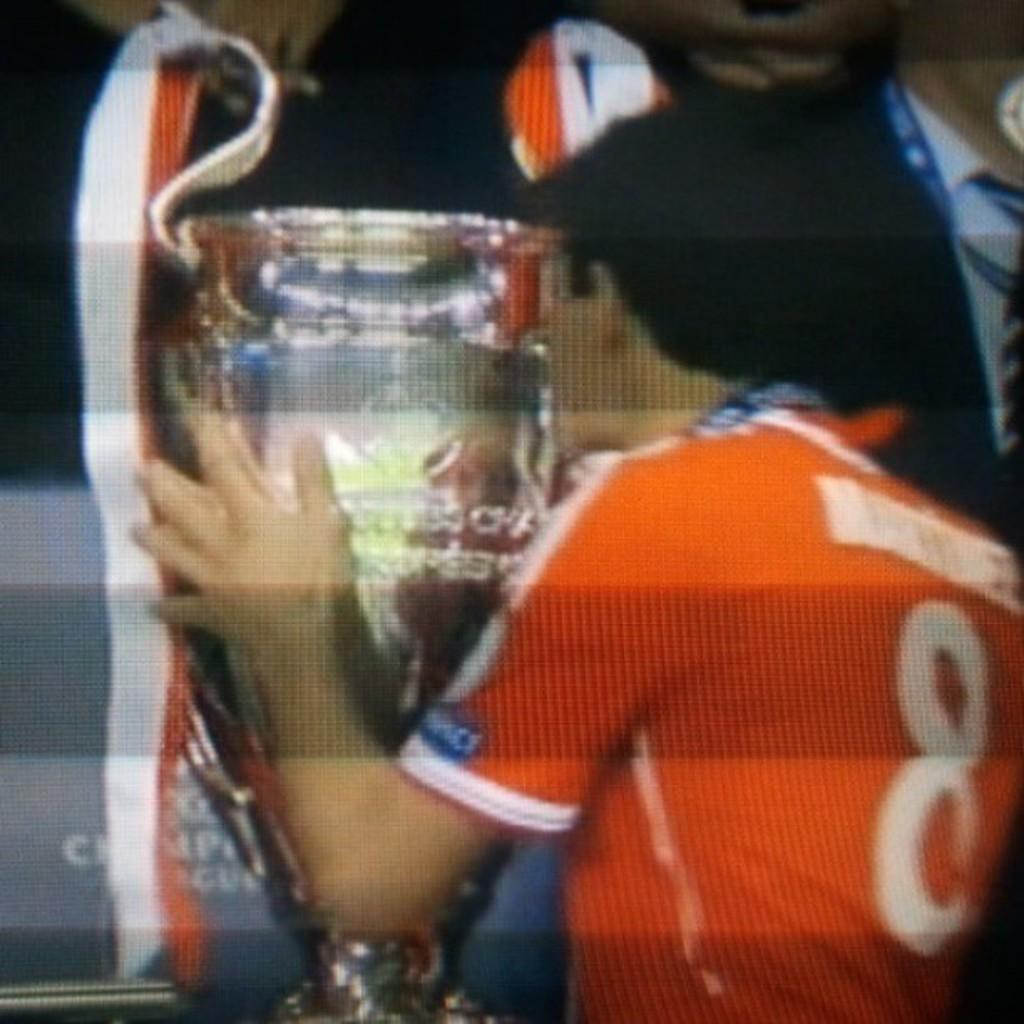Provide a one-sentence caption for the provided image. the man wearing an orange colored number 8 jersey. 